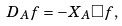<formula> <loc_0><loc_0><loc_500><loc_500>D _ { A } f = - X _ { A } \Box f ,</formula> 